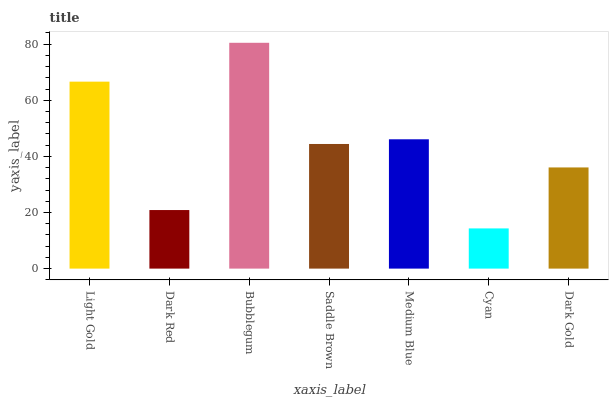Is Cyan the minimum?
Answer yes or no. Yes. Is Bubblegum the maximum?
Answer yes or no. Yes. Is Dark Red the minimum?
Answer yes or no. No. Is Dark Red the maximum?
Answer yes or no. No. Is Light Gold greater than Dark Red?
Answer yes or no. Yes. Is Dark Red less than Light Gold?
Answer yes or no. Yes. Is Dark Red greater than Light Gold?
Answer yes or no. No. Is Light Gold less than Dark Red?
Answer yes or no. No. Is Saddle Brown the high median?
Answer yes or no. Yes. Is Saddle Brown the low median?
Answer yes or no. Yes. Is Light Gold the high median?
Answer yes or no. No. Is Dark Red the low median?
Answer yes or no. No. 